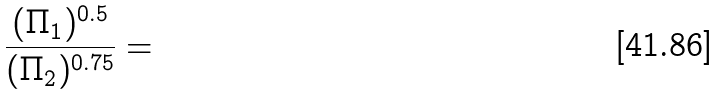<formula> <loc_0><loc_0><loc_500><loc_500>\frac { ( \Pi _ { 1 } ) ^ { 0 . 5 } } { ( \Pi _ { 2 } ) ^ { 0 . 7 5 } } =</formula> 